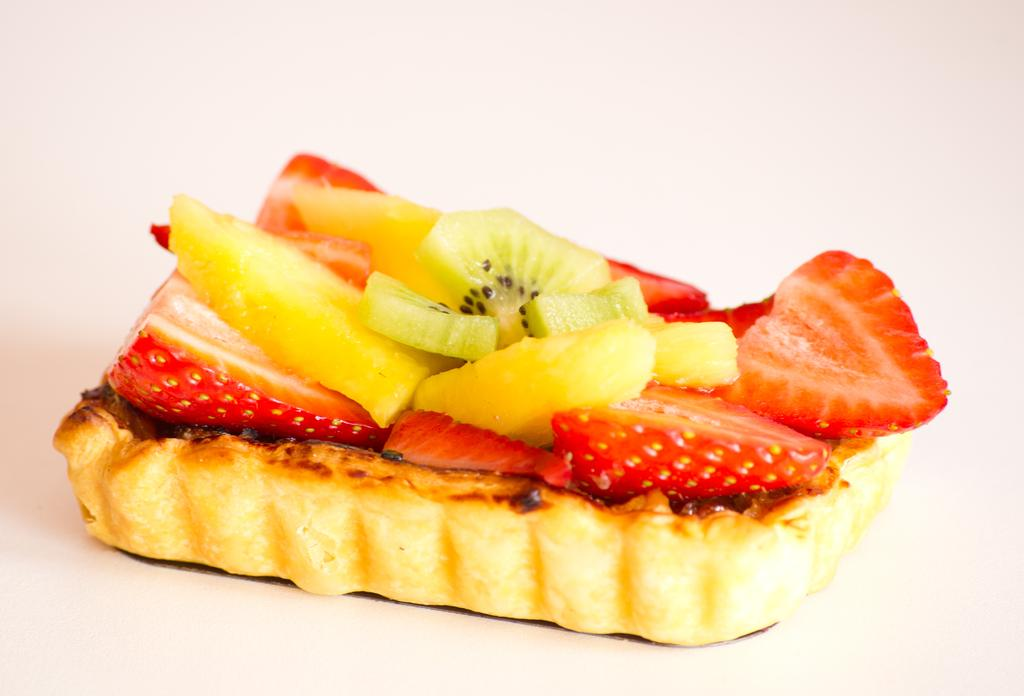What is the main subject of the image? There is a baked item in the center of the image. What types of fruit can be seen in the baked item? The baked item contains slices of strawberry, kiwi, and other fruit. How many rings are visible on the baked item in the image? There are no rings visible on the baked item in the image. What force is being applied to the baked item in the image? There is no force being applied to the baked item in the image; it is stationary. 